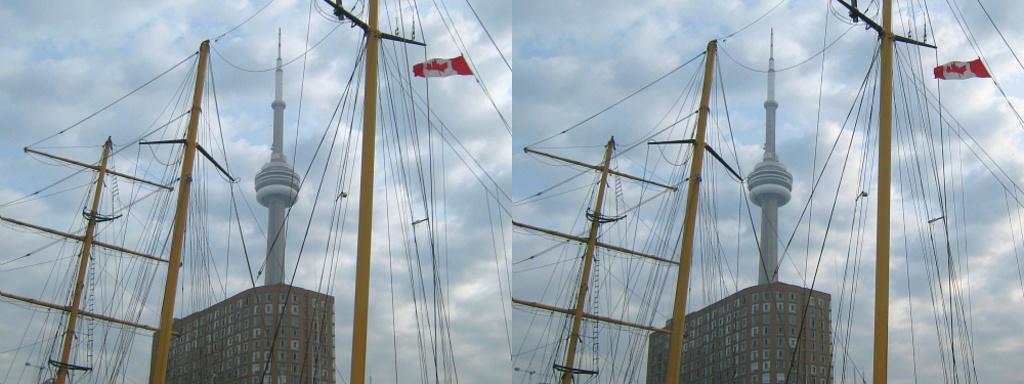Can you describe this image briefly? In this image I can see two same pictures. I can see a building which is brown in color, a tower, few yellow colored poles, few wires and a flag. In the background I can see the sky. 